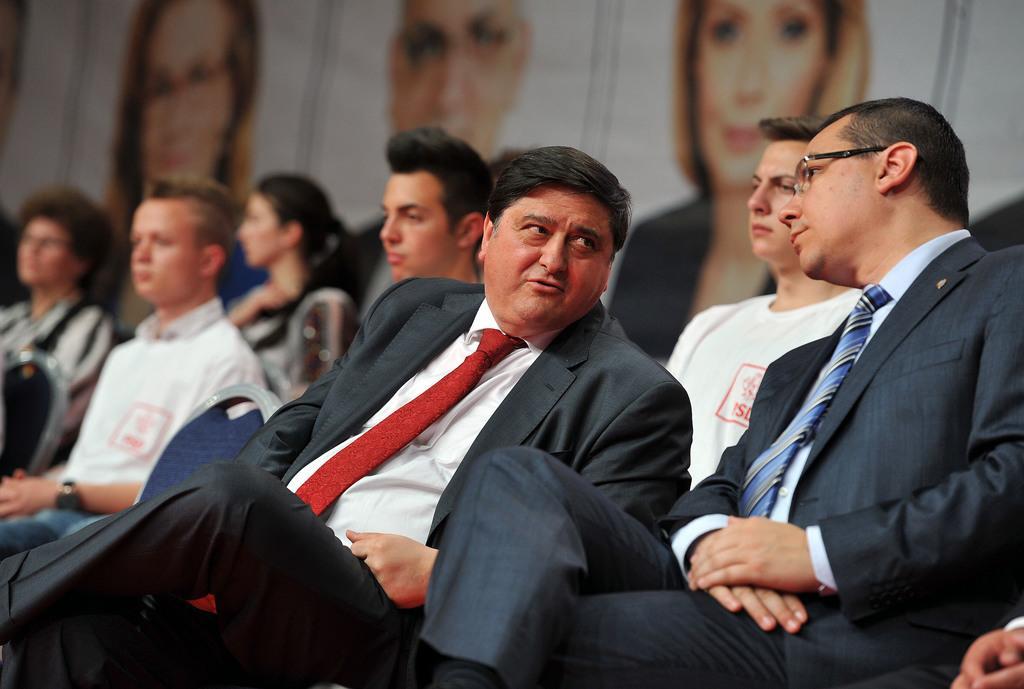In one or two sentences, can you explain what this image depicts? In the image there are a group of people and in the foreground there are three men, one of them is talking something and the background of the people is blur. 